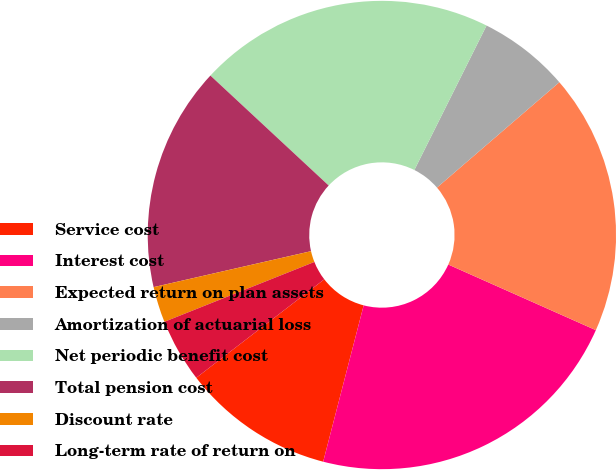Convert chart to OTSL. <chart><loc_0><loc_0><loc_500><loc_500><pie_chart><fcel>Service cost<fcel>Interest cost<fcel>Expected return on plan assets<fcel>Amortization of actuarial loss<fcel>Net periodic benefit cost<fcel>Total pension cost<fcel>Discount rate<fcel>Long-term rate of return on<nl><fcel>10.53%<fcel>22.37%<fcel>17.97%<fcel>6.31%<fcel>20.45%<fcel>15.49%<fcel>2.47%<fcel>4.39%<nl></chart> 